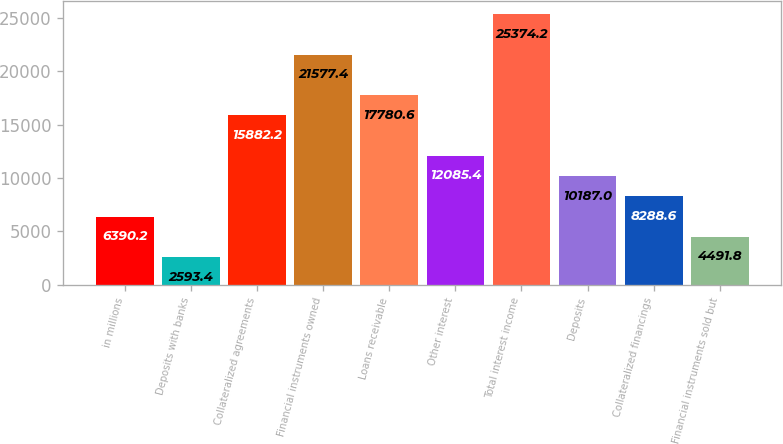Convert chart to OTSL. <chart><loc_0><loc_0><loc_500><loc_500><bar_chart><fcel>in millions<fcel>Deposits with banks<fcel>Collateralized agreements<fcel>Financial instruments owned<fcel>Loans receivable<fcel>Other interest<fcel>Total interest income<fcel>Deposits<fcel>Collateralized financings<fcel>Financial instruments sold but<nl><fcel>6390.2<fcel>2593.4<fcel>15882.2<fcel>21577.4<fcel>17780.6<fcel>12085.4<fcel>25374.2<fcel>10187<fcel>8288.6<fcel>4491.8<nl></chart> 